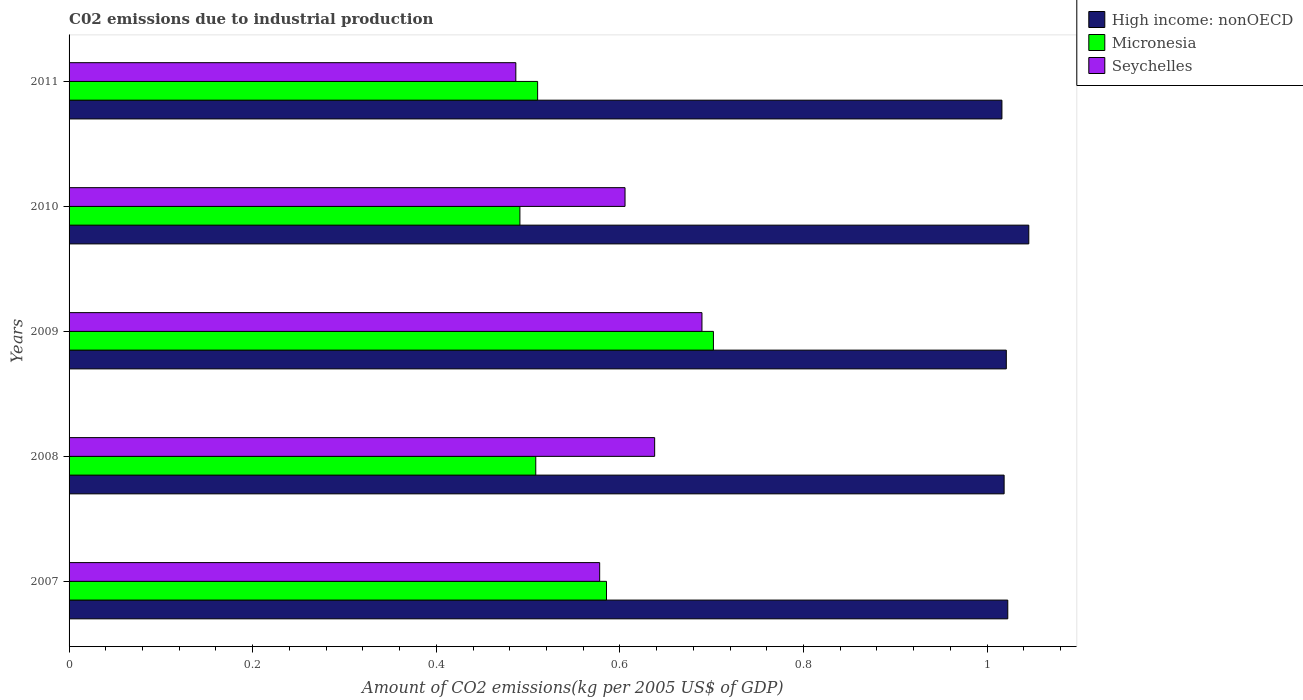How many different coloured bars are there?
Provide a short and direct response. 3. Are the number of bars per tick equal to the number of legend labels?
Your answer should be compact. Yes. Are the number of bars on each tick of the Y-axis equal?
Offer a very short reply. Yes. How many bars are there on the 5th tick from the bottom?
Provide a short and direct response. 3. What is the label of the 2nd group of bars from the top?
Offer a terse response. 2010. What is the amount of CO2 emitted due to industrial production in Micronesia in 2011?
Ensure brevity in your answer.  0.51. Across all years, what is the maximum amount of CO2 emitted due to industrial production in Seychelles?
Make the answer very short. 0.69. Across all years, what is the minimum amount of CO2 emitted due to industrial production in Seychelles?
Provide a short and direct response. 0.49. In which year was the amount of CO2 emitted due to industrial production in Seychelles maximum?
Your response must be concise. 2009. In which year was the amount of CO2 emitted due to industrial production in Seychelles minimum?
Your response must be concise. 2011. What is the total amount of CO2 emitted due to industrial production in Seychelles in the graph?
Make the answer very short. 3. What is the difference between the amount of CO2 emitted due to industrial production in High income: nonOECD in 2007 and that in 2010?
Give a very brief answer. -0.02. What is the difference between the amount of CO2 emitted due to industrial production in Micronesia in 2009 and the amount of CO2 emitted due to industrial production in High income: nonOECD in 2007?
Your response must be concise. -0.32. What is the average amount of CO2 emitted due to industrial production in Seychelles per year?
Ensure brevity in your answer.  0.6. In the year 2011, what is the difference between the amount of CO2 emitted due to industrial production in Seychelles and amount of CO2 emitted due to industrial production in Micronesia?
Provide a short and direct response. -0.02. What is the ratio of the amount of CO2 emitted due to industrial production in Micronesia in 2007 to that in 2011?
Keep it short and to the point. 1.15. What is the difference between the highest and the second highest amount of CO2 emitted due to industrial production in Seychelles?
Ensure brevity in your answer.  0.05. What is the difference between the highest and the lowest amount of CO2 emitted due to industrial production in High income: nonOECD?
Your response must be concise. 0.03. Is the sum of the amount of CO2 emitted due to industrial production in High income: nonOECD in 2009 and 2011 greater than the maximum amount of CO2 emitted due to industrial production in Micronesia across all years?
Offer a very short reply. Yes. What does the 2nd bar from the top in 2007 represents?
Provide a short and direct response. Micronesia. What does the 3rd bar from the bottom in 2011 represents?
Keep it short and to the point. Seychelles. How many bars are there?
Offer a very short reply. 15. Are the values on the major ticks of X-axis written in scientific E-notation?
Keep it short and to the point. No. Where does the legend appear in the graph?
Your answer should be very brief. Top right. How are the legend labels stacked?
Your answer should be compact. Vertical. What is the title of the graph?
Offer a terse response. C02 emissions due to industrial production. Does "Aruba" appear as one of the legend labels in the graph?
Your answer should be very brief. No. What is the label or title of the X-axis?
Keep it short and to the point. Amount of CO2 emissions(kg per 2005 US$ of GDP). What is the Amount of CO2 emissions(kg per 2005 US$ of GDP) of High income: nonOECD in 2007?
Make the answer very short. 1.02. What is the Amount of CO2 emissions(kg per 2005 US$ of GDP) in Micronesia in 2007?
Offer a very short reply. 0.59. What is the Amount of CO2 emissions(kg per 2005 US$ of GDP) of Seychelles in 2007?
Give a very brief answer. 0.58. What is the Amount of CO2 emissions(kg per 2005 US$ of GDP) in High income: nonOECD in 2008?
Offer a very short reply. 1.02. What is the Amount of CO2 emissions(kg per 2005 US$ of GDP) of Micronesia in 2008?
Provide a succinct answer. 0.51. What is the Amount of CO2 emissions(kg per 2005 US$ of GDP) in Seychelles in 2008?
Offer a very short reply. 0.64. What is the Amount of CO2 emissions(kg per 2005 US$ of GDP) of High income: nonOECD in 2009?
Provide a short and direct response. 1.02. What is the Amount of CO2 emissions(kg per 2005 US$ of GDP) of Micronesia in 2009?
Make the answer very short. 0.7. What is the Amount of CO2 emissions(kg per 2005 US$ of GDP) of Seychelles in 2009?
Your answer should be compact. 0.69. What is the Amount of CO2 emissions(kg per 2005 US$ of GDP) of High income: nonOECD in 2010?
Offer a terse response. 1.05. What is the Amount of CO2 emissions(kg per 2005 US$ of GDP) of Micronesia in 2010?
Your answer should be very brief. 0.49. What is the Amount of CO2 emissions(kg per 2005 US$ of GDP) of Seychelles in 2010?
Provide a short and direct response. 0.61. What is the Amount of CO2 emissions(kg per 2005 US$ of GDP) in High income: nonOECD in 2011?
Offer a very short reply. 1.02. What is the Amount of CO2 emissions(kg per 2005 US$ of GDP) of Micronesia in 2011?
Offer a very short reply. 0.51. What is the Amount of CO2 emissions(kg per 2005 US$ of GDP) of Seychelles in 2011?
Keep it short and to the point. 0.49. Across all years, what is the maximum Amount of CO2 emissions(kg per 2005 US$ of GDP) of High income: nonOECD?
Make the answer very short. 1.05. Across all years, what is the maximum Amount of CO2 emissions(kg per 2005 US$ of GDP) of Micronesia?
Offer a terse response. 0.7. Across all years, what is the maximum Amount of CO2 emissions(kg per 2005 US$ of GDP) of Seychelles?
Your answer should be compact. 0.69. Across all years, what is the minimum Amount of CO2 emissions(kg per 2005 US$ of GDP) in High income: nonOECD?
Make the answer very short. 1.02. Across all years, what is the minimum Amount of CO2 emissions(kg per 2005 US$ of GDP) in Micronesia?
Offer a very short reply. 0.49. Across all years, what is the minimum Amount of CO2 emissions(kg per 2005 US$ of GDP) of Seychelles?
Offer a terse response. 0.49. What is the total Amount of CO2 emissions(kg per 2005 US$ of GDP) of High income: nonOECD in the graph?
Your answer should be very brief. 5.12. What is the total Amount of CO2 emissions(kg per 2005 US$ of GDP) in Micronesia in the graph?
Your answer should be very brief. 2.8. What is the total Amount of CO2 emissions(kg per 2005 US$ of GDP) of Seychelles in the graph?
Keep it short and to the point. 3. What is the difference between the Amount of CO2 emissions(kg per 2005 US$ of GDP) of High income: nonOECD in 2007 and that in 2008?
Provide a short and direct response. 0. What is the difference between the Amount of CO2 emissions(kg per 2005 US$ of GDP) of Micronesia in 2007 and that in 2008?
Provide a short and direct response. 0.08. What is the difference between the Amount of CO2 emissions(kg per 2005 US$ of GDP) in Seychelles in 2007 and that in 2008?
Provide a succinct answer. -0.06. What is the difference between the Amount of CO2 emissions(kg per 2005 US$ of GDP) of High income: nonOECD in 2007 and that in 2009?
Keep it short and to the point. 0. What is the difference between the Amount of CO2 emissions(kg per 2005 US$ of GDP) in Micronesia in 2007 and that in 2009?
Ensure brevity in your answer.  -0.12. What is the difference between the Amount of CO2 emissions(kg per 2005 US$ of GDP) of Seychelles in 2007 and that in 2009?
Give a very brief answer. -0.11. What is the difference between the Amount of CO2 emissions(kg per 2005 US$ of GDP) of High income: nonOECD in 2007 and that in 2010?
Ensure brevity in your answer.  -0.02. What is the difference between the Amount of CO2 emissions(kg per 2005 US$ of GDP) in Micronesia in 2007 and that in 2010?
Make the answer very short. 0.09. What is the difference between the Amount of CO2 emissions(kg per 2005 US$ of GDP) in Seychelles in 2007 and that in 2010?
Offer a very short reply. -0.03. What is the difference between the Amount of CO2 emissions(kg per 2005 US$ of GDP) in High income: nonOECD in 2007 and that in 2011?
Provide a short and direct response. 0.01. What is the difference between the Amount of CO2 emissions(kg per 2005 US$ of GDP) in Micronesia in 2007 and that in 2011?
Offer a very short reply. 0.07. What is the difference between the Amount of CO2 emissions(kg per 2005 US$ of GDP) in Seychelles in 2007 and that in 2011?
Your response must be concise. 0.09. What is the difference between the Amount of CO2 emissions(kg per 2005 US$ of GDP) in High income: nonOECD in 2008 and that in 2009?
Your response must be concise. -0. What is the difference between the Amount of CO2 emissions(kg per 2005 US$ of GDP) in Micronesia in 2008 and that in 2009?
Your response must be concise. -0.19. What is the difference between the Amount of CO2 emissions(kg per 2005 US$ of GDP) of Seychelles in 2008 and that in 2009?
Keep it short and to the point. -0.05. What is the difference between the Amount of CO2 emissions(kg per 2005 US$ of GDP) in High income: nonOECD in 2008 and that in 2010?
Provide a short and direct response. -0.03. What is the difference between the Amount of CO2 emissions(kg per 2005 US$ of GDP) in Micronesia in 2008 and that in 2010?
Your answer should be very brief. 0.02. What is the difference between the Amount of CO2 emissions(kg per 2005 US$ of GDP) in Seychelles in 2008 and that in 2010?
Make the answer very short. 0.03. What is the difference between the Amount of CO2 emissions(kg per 2005 US$ of GDP) of High income: nonOECD in 2008 and that in 2011?
Your answer should be very brief. 0. What is the difference between the Amount of CO2 emissions(kg per 2005 US$ of GDP) in Micronesia in 2008 and that in 2011?
Provide a succinct answer. -0. What is the difference between the Amount of CO2 emissions(kg per 2005 US$ of GDP) of Seychelles in 2008 and that in 2011?
Offer a terse response. 0.15. What is the difference between the Amount of CO2 emissions(kg per 2005 US$ of GDP) in High income: nonOECD in 2009 and that in 2010?
Give a very brief answer. -0.02. What is the difference between the Amount of CO2 emissions(kg per 2005 US$ of GDP) in Micronesia in 2009 and that in 2010?
Your response must be concise. 0.21. What is the difference between the Amount of CO2 emissions(kg per 2005 US$ of GDP) of Seychelles in 2009 and that in 2010?
Offer a very short reply. 0.08. What is the difference between the Amount of CO2 emissions(kg per 2005 US$ of GDP) in High income: nonOECD in 2009 and that in 2011?
Your answer should be very brief. 0. What is the difference between the Amount of CO2 emissions(kg per 2005 US$ of GDP) of Micronesia in 2009 and that in 2011?
Provide a succinct answer. 0.19. What is the difference between the Amount of CO2 emissions(kg per 2005 US$ of GDP) of Seychelles in 2009 and that in 2011?
Your response must be concise. 0.2. What is the difference between the Amount of CO2 emissions(kg per 2005 US$ of GDP) in High income: nonOECD in 2010 and that in 2011?
Offer a very short reply. 0.03. What is the difference between the Amount of CO2 emissions(kg per 2005 US$ of GDP) of Micronesia in 2010 and that in 2011?
Your response must be concise. -0.02. What is the difference between the Amount of CO2 emissions(kg per 2005 US$ of GDP) of Seychelles in 2010 and that in 2011?
Provide a succinct answer. 0.12. What is the difference between the Amount of CO2 emissions(kg per 2005 US$ of GDP) in High income: nonOECD in 2007 and the Amount of CO2 emissions(kg per 2005 US$ of GDP) in Micronesia in 2008?
Ensure brevity in your answer.  0.51. What is the difference between the Amount of CO2 emissions(kg per 2005 US$ of GDP) in High income: nonOECD in 2007 and the Amount of CO2 emissions(kg per 2005 US$ of GDP) in Seychelles in 2008?
Make the answer very short. 0.38. What is the difference between the Amount of CO2 emissions(kg per 2005 US$ of GDP) in Micronesia in 2007 and the Amount of CO2 emissions(kg per 2005 US$ of GDP) in Seychelles in 2008?
Offer a very short reply. -0.05. What is the difference between the Amount of CO2 emissions(kg per 2005 US$ of GDP) of High income: nonOECD in 2007 and the Amount of CO2 emissions(kg per 2005 US$ of GDP) of Micronesia in 2009?
Your response must be concise. 0.32. What is the difference between the Amount of CO2 emissions(kg per 2005 US$ of GDP) in High income: nonOECD in 2007 and the Amount of CO2 emissions(kg per 2005 US$ of GDP) in Seychelles in 2009?
Offer a terse response. 0.33. What is the difference between the Amount of CO2 emissions(kg per 2005 US$ of GDP) in Micronesia in 2007 and the Amount of CO2 emissions(kg per 2005 US$ of GDP) in Seychelles in 2009?
Your answer should be very brief. -0.1. What is the difference between the Amount of CO2 emissions(kg per 2005 US$ of GDP) of High income: nonOECD in 2007 and the Amount of CO2 emissions(kg per 2005 US$ of GDP) of Micronesia in 2010?
Provide a short and direct response. 0.53. What is the difference between the Amount of CO2 emissions(kg per 2005 US$ of GDP) in High income: nonOECD in 2007 and the Amount of CO2 emissions(kg per 2005 US$ of GDP) in Seychelles in 2010?
Offer a terse response. 0.42. What is the difference between the Amount of CO2 emissions(kg per 2005 US$ of GDP) of Micronesia in 2007 and the Amount of CO2 emissions(kg per 2005 US$ of GDP) of Seychelles in 2010?
Provide a succinct answer. -0.02. What is the difference between the Amount of CO2 emissions(kg per 2005 US$ of GDP) of High income: nonOECD in 2007 and the Amount of CO2 emissions(kg per 2005 US$ of GDP) of Micronesia in 2011?
Ensure brevity in your answer.  0.51. What is the difference between the Amount of CO2 emissions(kg per 2005 US$ of GDP) of High income: nonOECD in 2007 and the Amount of CO2 emissions(kg per 2005 US$ of GDP) of Seychelles in 2011?
Keep it short and to the point. 0.54. What is the difference between the Amount of CO2 emissions(kg per 2005 US$ of GDP) in Micronesia in 2007 and the Amount of CO2 emissions(kg per 2005 US$ of GDP) in Seychelles in 2011?
Your response must be concise. 0.1. What is the difference between the Amount of CO2 emissions(kg per 2005 US$ of GDP) in High income: nonOECD in 2008 and the Amount of CO2 emissions(kg per 2005 US$ of GDP) in Micronesia in 2009?
Your response must be concise. 0.32. What is the difference between the Amount of CO2 emissions(kg per 2005 US$ of GDP) of High income: nonOECD in 2008 and the Amount of CO2 emissions(kg per 2005 US$ of GDP) of Seychelles in 2009?
Give a very brief answer. 0.33. What is the difference between the Amount of CO2 emissions(kg per 2005 US$ of GDP) of Micronesia in 2008 and the Amount of CO2 emissions(kg per 2005 US$ of GDP) of Seychelles in 2009?
Provide a short and direct response. -0.18. What is the difference between the Amount of CO2 emissions(kg per 2005 US$ of GDP) in High income: nonOECD in 2008 and the Amount of CO2 emissions(kg per 2005 US$ of GDP) in Micronesia in 2010?
Make the answer very short. 0.53. What is the difference between the Amount of CO2 emissions(kg per 2005 US$ of GDP) of High income: nonOECD in 2008 and the Amount of CO2 emissions(kg per 2005 US$ of GDP) of Seychelles in 2010?
Provide a succinct answer. 0.41. What is the difference between the Amount of CO2 emissions(kg per 2005 US$ of GDP) in Micronesia in 2008 and the Amount of CO2 emissions(kg per 2005 US$ of GDP) in Seychelles in 2010?
Your response must be concise. -0.1. What is the difference between the Amount of CO2 emissions(kg per 2005 US$ of GDP) of High income: nonOECD in 2008 and the Amount of CO2 emissions(kg per 2005 US$ of GDP) of Micronesia in 2011?
Offer a terse response. 0.51. What is the difference between the Amount of CO2 emissions(kg per 2005 US$ of GDP) in High income: nonOECD in 2008 and the Amount of CO2 emissions(kg per 2005 US$ of GDP) in Seychelles in 2011?
Your answer should be compact. 0.53. What is the difference between the Amount of CO2 emissions(kg per 2005 US$ of GDP) of Micronesia in 2008 and the Amount of CO2 emissions(kg per 2005 US$ of GDP) of Seychelles in 2011?
Give a very brief answer. 0.02. What is the difference between the Amount of CO2 emissions(kg per 2005 US$ of GDP) of High income: nonOECD in 2009 and the Amount of CO2 emissions(kg per 2005 US$ of GDP) of Micronesia in 2010?
Your response must be concise. 0.53. What is the difference between the Amount of CO2 emissions(kg per 2005 US$ of GDP) of High income: nonOECD in 2009 and the Amount of CO2 emissions(kg per 2005 US$ of GDP) of Seychelles in 2010?
Your response must be concise. 0.42. What is the difference between the Amount of CO2 emissions(kg per 2005 US$ of GDP) in Micronesia in 2009 and the Amount of CO2 emissions(kg per 2005 US$ of GDP) in Seychelles in 2010?
Keep it short and to the point. 0.1. What is the difference between the Amount of CO2 emissions(kg per 2005 US$ of GDP) of High income: nonOECD in 2009 and the Amount of CO2 emissions(kg per 2005 US$ of GDP) of Micronesia in 2011?
Your answer should be very brief. 0.51. What is the difference between the Amount of CO2 emissions(kg per 2005 US$ of GDP) in High income: nonOECD in 2009 and the Amount of CO2 emissions(kg per 2005 US$ of GDP) in Seychelles in 2011?
Offer a very short reply. 0.53. What is the difference between the Amount of CO2 emissions(kg per 2005 US$ of GDP) in Micronesia in 2009 and the Amount of CO2 emissions(kg per 2005 US$ of GDP) in Seychelles in 2011?
Your answer should be compact. 0.22. What is the difference between the Amount of CO2 emissions(kg per 2005 US$ of GDP) of High income: nonOECD in 2010 and the Amount of CO2 emissions(kg per 2005 US$ of GDP) of Micronesia in 2011?
Give a very brief answer. 0.54. What is the difference between the Amount of CO2 emissions(kg per 2005 US$ of GDP) in High income: nonOECD in 2010 and the Amount of CO2 emissions(kg per 2005 US$ of GDP) in Seychelles in 2011?
Provide a short and direct response. 0.56. What is the difference between the Amount of CO2 emissions(kg per 2005 US$ of GDP) of Micronesia in 2010 and the Amount of CO2 emissions(kg per 2005 US$ of GDP) of Seychelles in 2011?
Offer a very short reply. 0. What is the average Amount of CO2 emissions(kg per 2005 US$ of GDP) of High income: nonOECD per year?
Provide a short and direct response. 1.02. What is the average Amount of CO2 emissions(kg per 2005 US$ of GDP) in Micronesia per year?
Provide a short and direct response. 0.56. What is the average Amount of CO2 emissions(kg per 2005 US$ of GDP) in Seychelles per year?
Keep it short and to the point. 0.6. In the year 2007, what is the difference between the Amount of CO2 emissions(kg per 2005 US$ of GDP) of High income: nonOECD and Amount of CO2 emissions(kg per 2005 US$ of GDP) of Micronesia?
Provide a short and direct response. 0.44. In the year 2007, what is the difference between the Amount of CO2 emissions(kg per 2005 US$ of GDP) in High income: nonOECD and Amount of CO2 emissions(kg per 2005 US$ of GDP) in Seychelles?
Make the answer very short. 0.44. In the year 2007, what is the difference between the Amount of CO2 emissions(kg per 2005 US$ of GDP) of Micronesia and Amount of CO2 emissions(kg per 2005 US$ of GDP) of Seychelles?
Give a very brief answer. 0.01. In the year 2008, what is the difference between the Amount of CO2 emissions(kg per 2005 US$ of GDP) of High income: nonOECD and Amount of CO2 emissions(kg per 2005 US$ of GDP) of Micronesia?
Your response must be concise. 0.51. In the year 2008, what is the difference between the Amount of CO2 emissions(kg per 2005 US$ of GDP) in High income: nonOECD and Amount of CO2 emissions(kg per 2005 US$ of GDP) in Seychelles?
Offer a terse response. 0.38. In the year 2008, what is the difference between the Amount of CO2 emissions(kg per 2005 US$ of GDP) in Micronesia and Amount of CO2 emissions(kg per 2005 US$ of GDP) in Seychelles?
Provide a succinct answer. -0.13. In the year 2009, what is the difference between the Amount of CO2 emissions(kg per 2005 US$ of GDP) of High income: nonOECD and Amount of CO2 emissions(kg per 2005 US$ of GDP) of Micronesia?
Provide a short and direct response. 0.32. In the year 2009, what is the difference between the Amount of CO2 emissions(kg per 2005 US$ of GDP) of High income: nonOECD and Amount of CO2 emissions(kg per 2005 US$ of GDP) of Seychelles?
Your response must be concise. 0.33. In the year 2009, what is the difference between the Amount of CO2 emissions(kg per 2005 US$ of GDP) of Micronesia and Amount of CO2 emissions(kg per 2005 US$ of GDP) of Seychelles?
Provide a short and direct response. 0.01. In the year 2010, what is the difference between the Amount of CO2 emissions(kg per 2005 US$ of GDP) of High income: nonOECD and Amount of CO2 emissions(kg per 2005 US$ of GDP) of Micronesia?
Your answer should be very brief. 0.55. In the year 2010, what is the difference between the Amount of CO2 emissions(kg per 2005 US$ of GDP) in High income: nonOECD and Amount of CO2 emissions(kg per 2005 US$ of GDP) in Seychelles?
Offer a very short reply. 0.44. In the year 2010, what is the difference between the Amount of CO2 emissions(kg per 2005 US$ of GDP) in Micronesia and Amount of CO2 emissions(kg per 2005 US$ of GDP) in Seychelles?
Provide a succinct answer. -0.11. In the year 2011, what is the difference between the Amount of CO2 emissions(kg per 2005 US$ of GDP) of High income: nonOECD and Amount of CO2 emissions(kg per 2005 US$ of GDP) of Micronesia?
Your answer should be very brief. 0.51. In the year 2011, what is the difference between the Amount of CO2 emissions(kg per 2005 US$ of GDP) of High income: nonOECD and Amount of CO2 emissions(kg per 2005 US$ of GDP) of Seychelles?
Offer a very short reply. 0.53. In the year 2011, what is the difference between the Amount of CO2 emissions(kg per 2005 US$ of GDP) of Micronesia and Amount of CO2 emissions(kg per 2005 US$ of GDP) of Seychelles?
Ensure brevity in your answer.  0.02. What is the ratio of the Amount of CO2 emissions(kg per 2005 US$ of GDP) of Micronesia in 2007 to that in 2008?
Give a very brief answer. 1.15. What is the ratio of the Amount of CO2 emissions(kg per 2005 US$ of GDP) in Seychelles in 2007 to that in 2008?
Give a very brief answer. 0.91. What is the ratio of the Amount of CO2 emissions(kg per 2005 US$ of GDP) of High income: nonOECD in 2007 to that in 2009?
Give a very brief answer. 1. What is the ratio of the Amount of CO2 emissions(kg per 2005 US$ of GDP) in Micronesia in 2007 to that in 2009?
Offer a very short reply. 0.83. What is the ratio of the Amount of CO2 emissions(kg per 2005 US$ of GDP) in Seychelles in 2007 to that in 2009?
Keep it short and to the point. 0.84. What is the ratio of the Amount of CO2 emissions(kg per 2005 US$ of GDP) in High income: nonOECD in 2007 to that in 2010?
Keep it short and to the point. 0.98. What is the ratio of the Amount of CO2 emissions(kg per 2005 US$ of GDP) of Micronesia in 2007 to that in 2010?
Offer a terse response. 1.19. What is the ratio of the Amount of CO2 emissions(kg per 2005 US$ of GDP) of Seychelles in 2007 to that in 2010?
Offer a terse response. 0.95. What is the ratio of the Amount of CO2 emissions(kg per 2005 US$ of GDP) in High income: nonOECD in 2007 to that in 2011?
Keep it short and to the point. 1.01. What is the ratio of the Amount of CO2 emissions(kg per 2005 US$ of GDP) of Micronesia in 2007 to that in 2011?
Make the answer very short. 1.15. What is the ratio of the Amount of CO2 emissions(kg per 2005 US$ of GDP) of Seychelles in 2007 to that in 2011?
Provide a succinct answer. 1.19. What is the ratio of the Amount of CO2 emissions(kg per 2005 US$ of GDP) in Micronesia in 2008 to that in 2009?
Offer a terse response. 0.72. What is the ratio of the Amount of CO2 emissions(kg per 2005 US$ of GDP) of Seychelles in 2008 to that in 2009?
Your answer should be very brief. 0.93. What is the ratio of the Amount of CO2 emissions(kg per 2005 US$ of GDP) in High income: nonOECD in 2008 to that in 2010?
Ensure brevity in your answer.  0.97. What is the ratio of the Amount of CO2 emissions(kg per 2005 US$ of GDP) in Micronesia in 2008 to that in 2010?
Your answer should be very brief. 1.04. What is the ratio of the Amount of CO2 emissions(kg per 2005 US$ of GDP) of Seychelles in 2008 to that in 2010?
Provide a succinct answer. 1.05. What is the ratio of the Amount of CO2 emissions(kg per 2005 US$ of GDP) of Micronesia in 2008 to that in 2011?
Your answer should be compact. 1. What is the ratio of the Amount of CO2 emissions(kg per 2005 US$ of GDP) in Seychelles in 2008 to that in 2011?
Ensure brevity in your answer.  1.31. What is the ratio of the Amount of CO2 emissions(kg per 2005 US$ of GDP) of High income: nonOECD in 2009 to that in 2010?
Your answer should be very brief. 0.98. What is the ratio of the Amount of CO2 emissions(kg per 2005 US$ of GDP) of Micronesia in 2009 to that in 2010?
Your answer should be compact. 1.43. What is the ratio of the Amount of CO2 emissions(kg per 2005 US$ of GDP) in Seychelles in 2009 to that in 2010?
Provide a succinct answer. 1.14. What is the ratio of the Amount of CO2 emissions(kg per 2005 US$ of GDP) of High income: nonOECD in 2009 to that in 2011?
Make the answer very short. 1. What is the ratio of the Amount of CO2 emissions(kg per 2005 US$ of GDP) in Micronesia in 2009 to that in 2011?
Your answer should be very brief. 1.38. What is the ratio of the Amount of CO2 emissions(kg per 2005 US$ of GDP) of Seychelles in 2009 to that in 2011?
Your answer should be compact. 1.42. What is the ratio of the Amount of CO2 emissions(kg per 2005 US$ of GDP) of High income: nonOECD in 2010 to that in 2011?
Make the answer very short. 1.03. What is the ratio of the Amount of CO2 emissions(kg per 2005 US$ of GDP) of Micronesia in 2010 to that in 2011?
Provide a short and direct response. 0.96. What is the ratio of the Amount of CO2 emissions(kg per 2005 US$ of GDP) in Seychelles in 2010 to that in 2011?
Provide a short and direct response. 1.24. What is the difference between the highest and the second highest Amount of CO2 emissions(kg per 2005 US$ of GDP) in High income: nonOECD?
Offer a very short reply. 0.02. What is the difference between the highest and the second highest Amount of CO2 emissions(kg per 2005 US$ of GDP) in Micronesia?
Provide a short and direct response. 0.12. What is the difference between the highest and the second highest Amount of CO2 emissions(kg per 2005 US$ of GDP) in Seychelles?
Your answer should be compact. 0.05. What is the difference between the highest and the lowest Amount of CO2 emissions(kg per 2005 US$ of GDP) in High income: nonOECD?
Ensure brevity in your answer.  0.03. What is the difference between the highest and the lowest Amount of CO2 emissions(kg per 2005 US$ of GDP) of Micronesia?
Your response must be concise. 0.21. What is the difference between the highest and the lowest Amount of CO2 emissions(kg per 2005 US$ of GDP) of Seychelles?
Your answer should be compact. 0.2. 